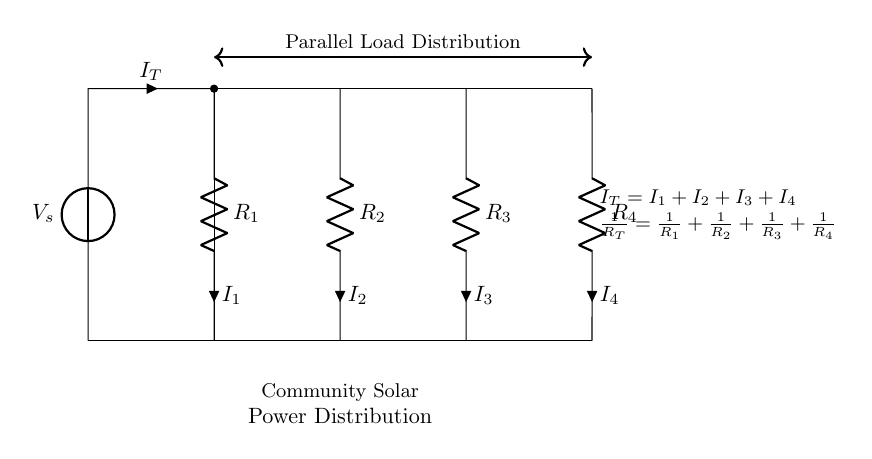What is the total current flowing in this circuit? The total current, denoted as I_T, is the sum of all the individual currents (I_1, I_2, I_3, I_4) flowing through the resistors in parallel. According to the diagram, we know the relationship is I_T = I_1 + I_2 + I_3 + I_4.
Answer: I_T What type of circuit is this? The circuit displayed is a parallel circuit because the resistors are connected alongside each other across the same voltage source, allowing multiple paths for current to flow.
Answer: Parallel circuit How many resistors are in this circuit? The diagram shows four resistors (R_1, R_2, R_3, R_4) connected in parallel, visible by the four distinct branches in the lower part of the circuit.
Answer: Four What is the relationship between resistances in parallel? For resistors in parallel, the total resistance (R_T) can be calculated using the formula 1/R_T = 1/R_1 + 1/R_2 + 1/R_3 + 1/R_4, indicating that the reciprocal of the total resistance equals the sum of the reciprocals of each individual resistance.
Answer: 1/R_T = 1/R_1 + 1/R_2 + 1/R_3 + 1/R_4 Which component receives the highest current? In a parallel circuit, the resistor with the lowest resistance receives the highest current due to Ohm's Law, where current is inversely proportional to resistance. Therefore, to determine which resistor receives the highest current, one would need to compare the values of R_1, R_2, R_3, and R_4.
Answer: The resistor with the lowest resistance receives the highest current 